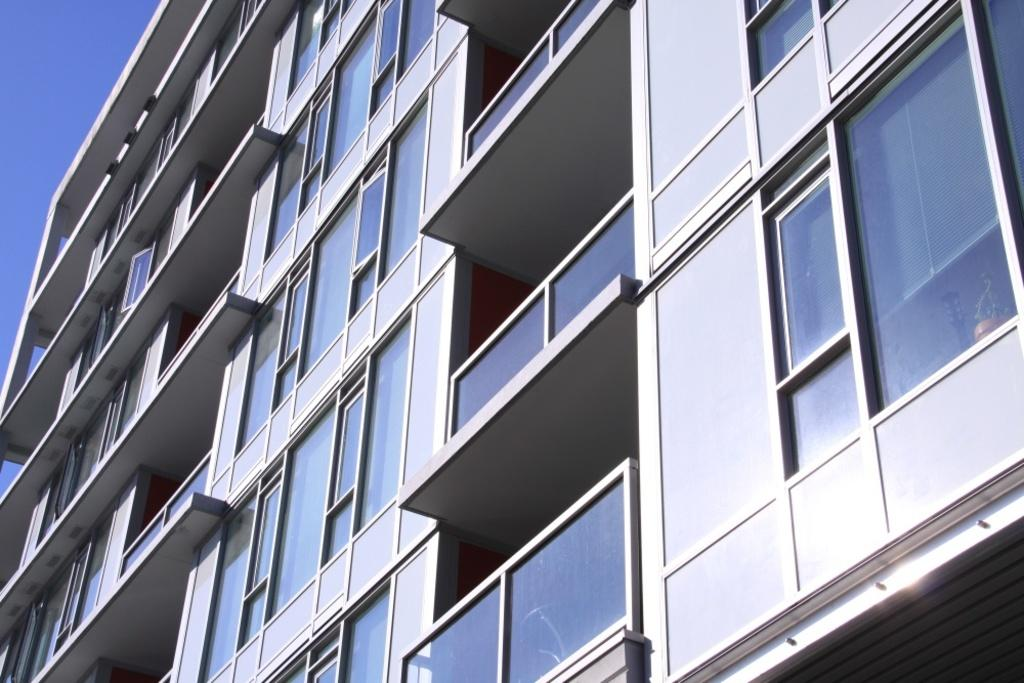What type of structure is present in the image? There is a building in the image. What feature can be seen on the building? The building has glass doors. What is visible in the background of the image? The sky is visible in the image. What type of coil can be seen wrapped around the building in the image? There is no coil present wrapped around the building in the image. How does the pail help with the throat issue in the image? There is no pail or throat issue present in the image. 